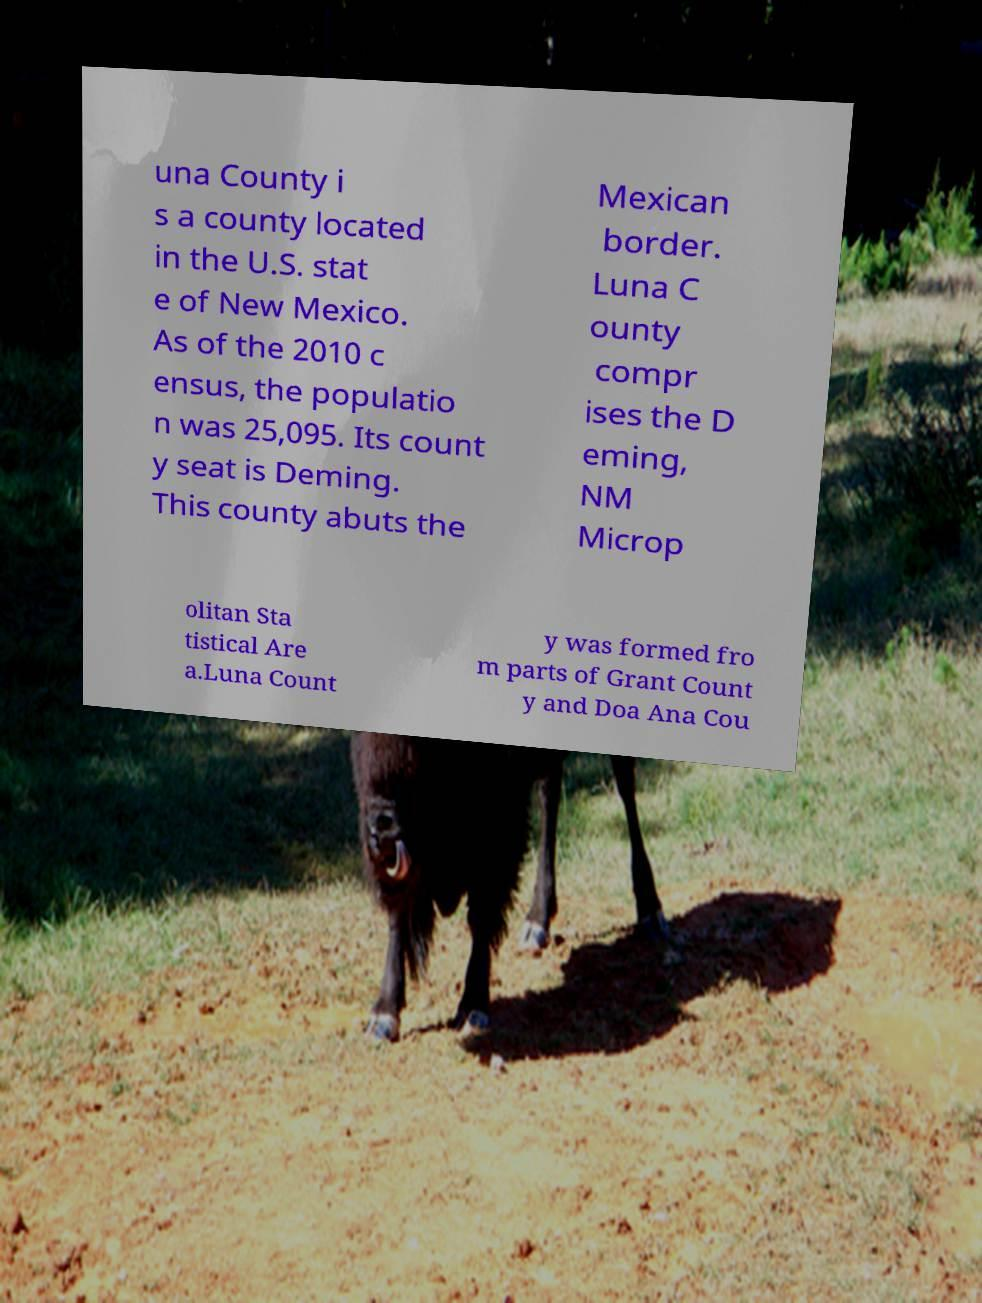Could you extract and type out the text from this image? una County i s a county located in the U.S. stat e of New Mexico. As of the 2010 c ensus, the populatio n was 25,095. Its count y seat is Deming. This county abuts the Mexican border. Luna C ounty compr ises the D eming, NM Microp olitan Sta tistical Are a.Luna Count y was formed fro m parts of Grant Count y and Doa Ana Cou 